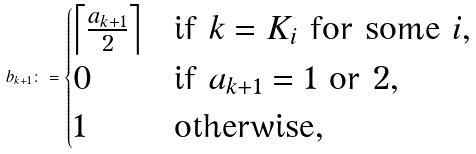<formula> <loc_0><loc_0><loc_500><loc_500>b _ { k + 1 } \colon = \begin{cases} \left \lceil \frac { a _ { k + 1 } } { 2 } \right \rceil & \text {if } k = K _ { i } \text { for some $i$} , \\ 0 & \text {if } a _ { k + 1 } = 1 \text { or } 2 , \\ 1 & \text {otherwise} , \end{cases}</formula> 